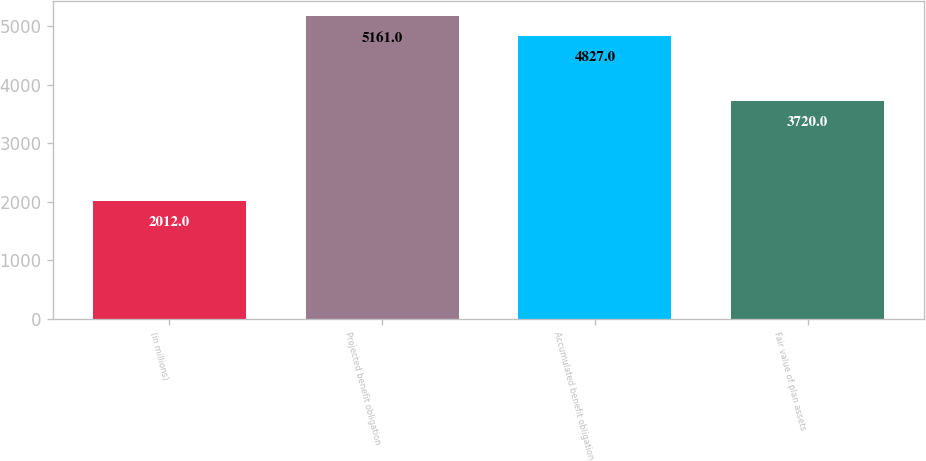Convert chart. <chart><loc_0><loc_0><loc_500><loc_500><bar_chart><fcel>(in millions)<fcel>Projected benefit obligation<fcel>Accumulated benefit obligation<fcel>Fair value of plan assets<nl><fcel>2012<fcel>5161<fcel>4827<fcel>3720<nl></chart> 